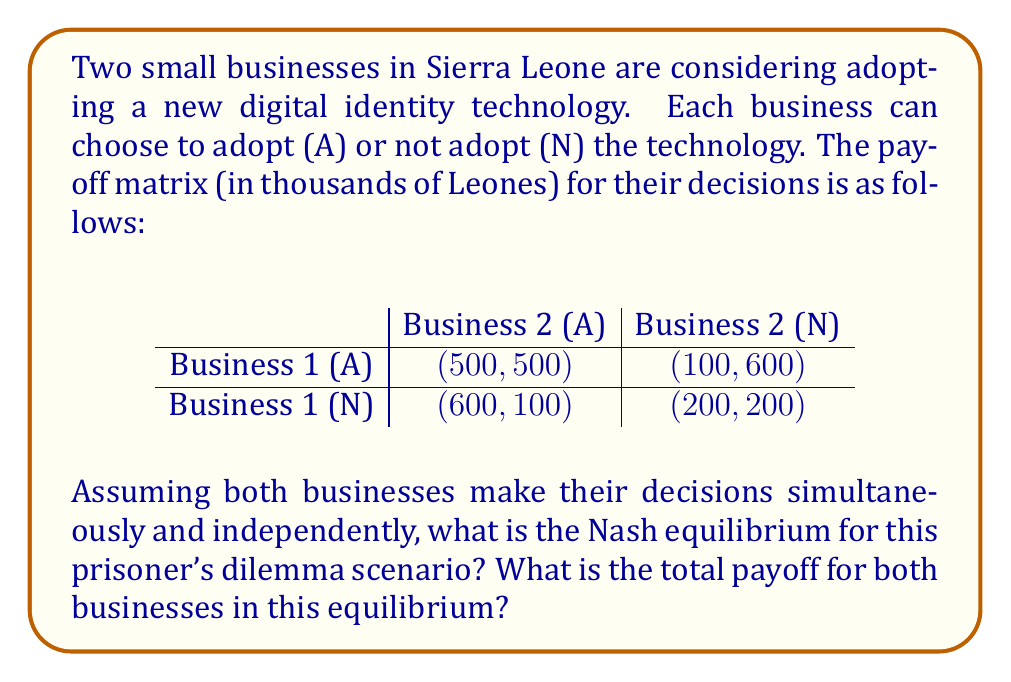Give your solution to this math problem. To solve this prisoner's dilemma scenario, we need to identify the Nash equilibrium. A Nash equilibrium occurs when neither player can unilaterally improve their payoff by changing their strategy.

Let's analyze each business's best response to the other's strategy:

1. If Business 2 adopts (A):
   - Business 1 choosing A: payoff = 500
   - Business 1 choosing N: payoff = 600
   Business 1's best response: N

2. If Business 2 does not adopt (N):
   - Business 1 choosing A: payoff = 100
   - Business 1 choosing N: payoff = 200
   Business 1's best response: N

3. If Business 1 adopts (A):
   - Business 2 choosing A: payoff = 500
   - Business 2 choosing N: payoff = 600
   Business 2's best response: N

4. If Business 1 does not adopt (N):
   - Business 2 choosing A: payoff = 100
   - Business 2 choosing N: payoff = 200
   Business 2's best response: N

We can see that regardless of what the other business does, the best response for each business is to not adopt (N). This means the Nash equilibrium is (N, N), where both businesses choose not to adopt the technology.

At this equilibrium point (N, N), the payoff for each business is 200 thousand Leones.

The total payoff for both businesses in this equilibrium is:

$$ \text{Total Payoff} = 200 + 200 = 400 \text{ thousand Leones} $$

It's worth noting that this outcome is not Pareto optimal, as both businesses would be better off if they both chose to adopt (A, A), which would result in a payoff of 500 thousand Leones each. This highlights the nature of the prisoner's dilemma, where individual rational choices lead to a suboptimal collective outcome.
Answer: The Nash equilibrium is (N, N), where both businesses choose not to adopt the technology. The total payoff for both businesses in this equilibrium is 400 thousand Leones. 